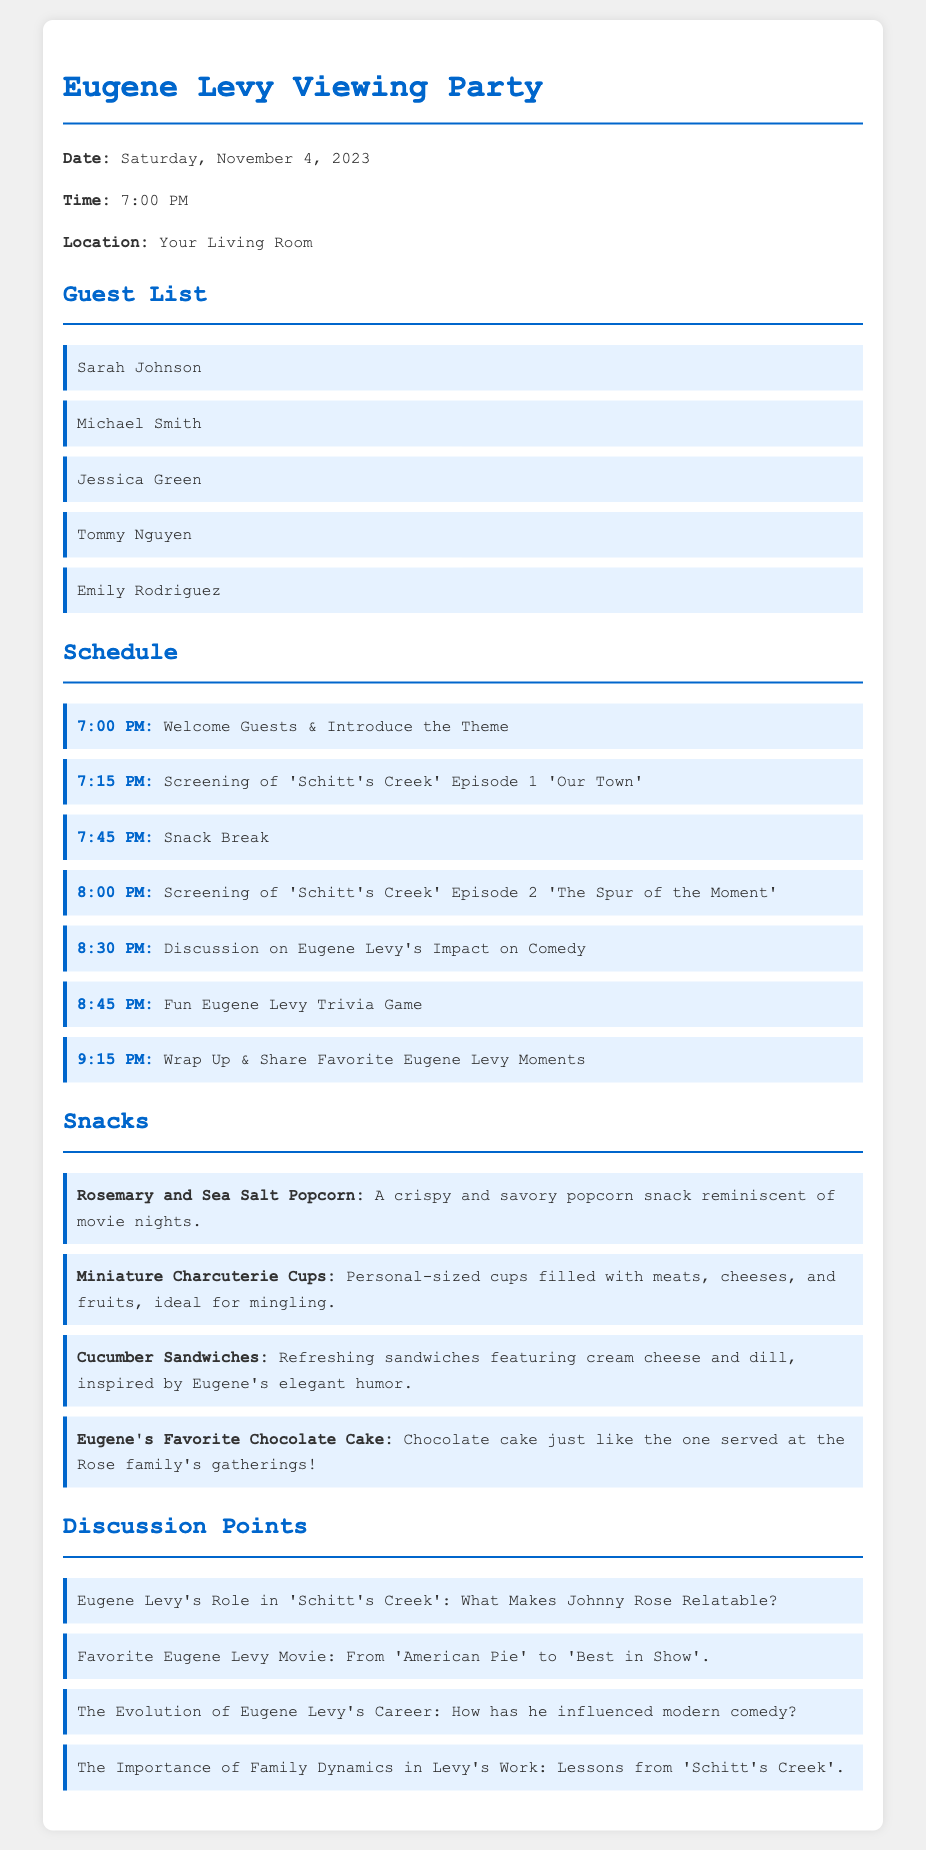What date is the viewing party scheduled for? The date is explicitly stated in the document as "Saturday, November 4, 2023."
Answer: Saturday, November 4, 2023 What time does the viewing party start? The document specifies the starting time as "7:00 PM."
Answer: 7:00 PM How many guests are invited? By counting the names listed under the guest list, there are five guests mentioned.
Answer: 5 What is the first scheduled activity? The first activity mentioned in the schedule is "Welcome Guests & Introduce the Theme," which occurs at 7:00 PM.
Answer: Welcome Guests & Introduce the Theme What snack is inspired by Eugene Levy's elegant humor? The document indicates that "Cucumber Sandwiches" are inspired by his humor as elaborated in the snacks section.
Answer: Cucumber Sandwiches Which episode of 'Schitt's Creek' is being screened first? The document states that the first episode being screened is "Episode 1 'Our Town'."
Answer: Episode 1 'Our Town' What topic is discussed after the snack break? After the snack break, the next discussion topic is "Eugene Levy's Impact on Comedy."
Answer: Eugene Levy's Impact on Comedy Which dessert is mentioned as Eugene's favorite? The document lists "Eugene's Favorite Chocolate Cake" as a snack option.
Answer: Eugene's Favorite Chocolate Cake What is one of the discussion points about family dynamics? The discussion point mentioned about family dynamics is "Lessons from 'Schitt's Creek'."
Answer: Lessons from 'Schitt's Creek' 